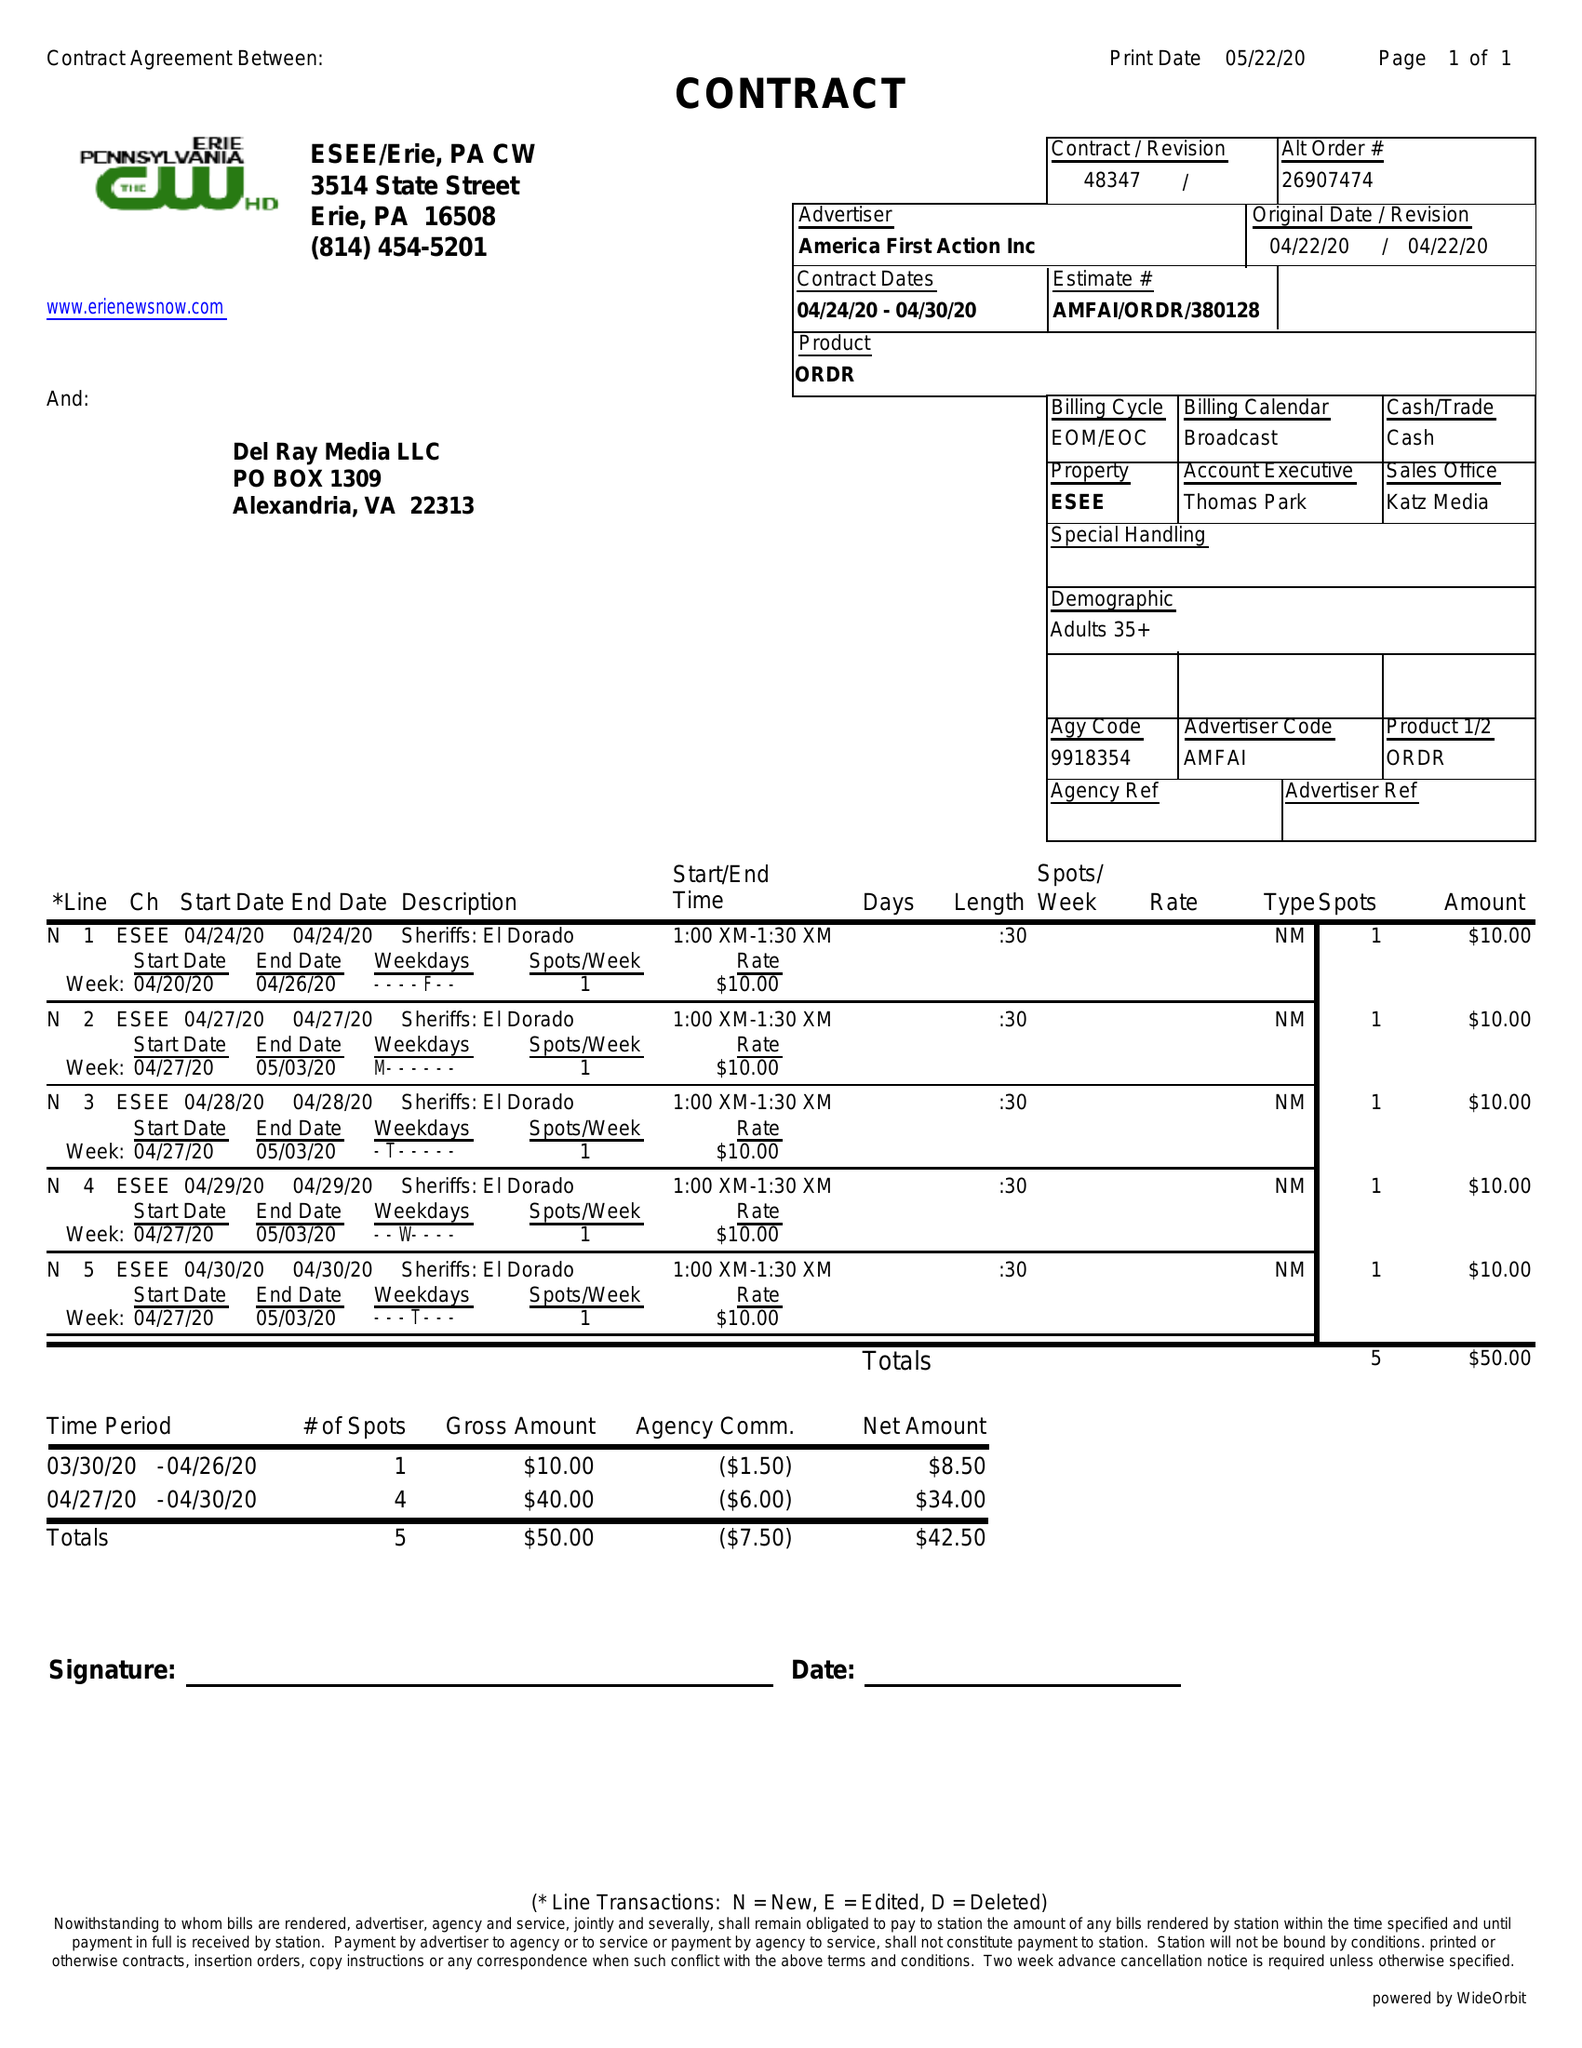What is the value for the flight_to?
Answer the question using a single word or phrase. 04/30/20 